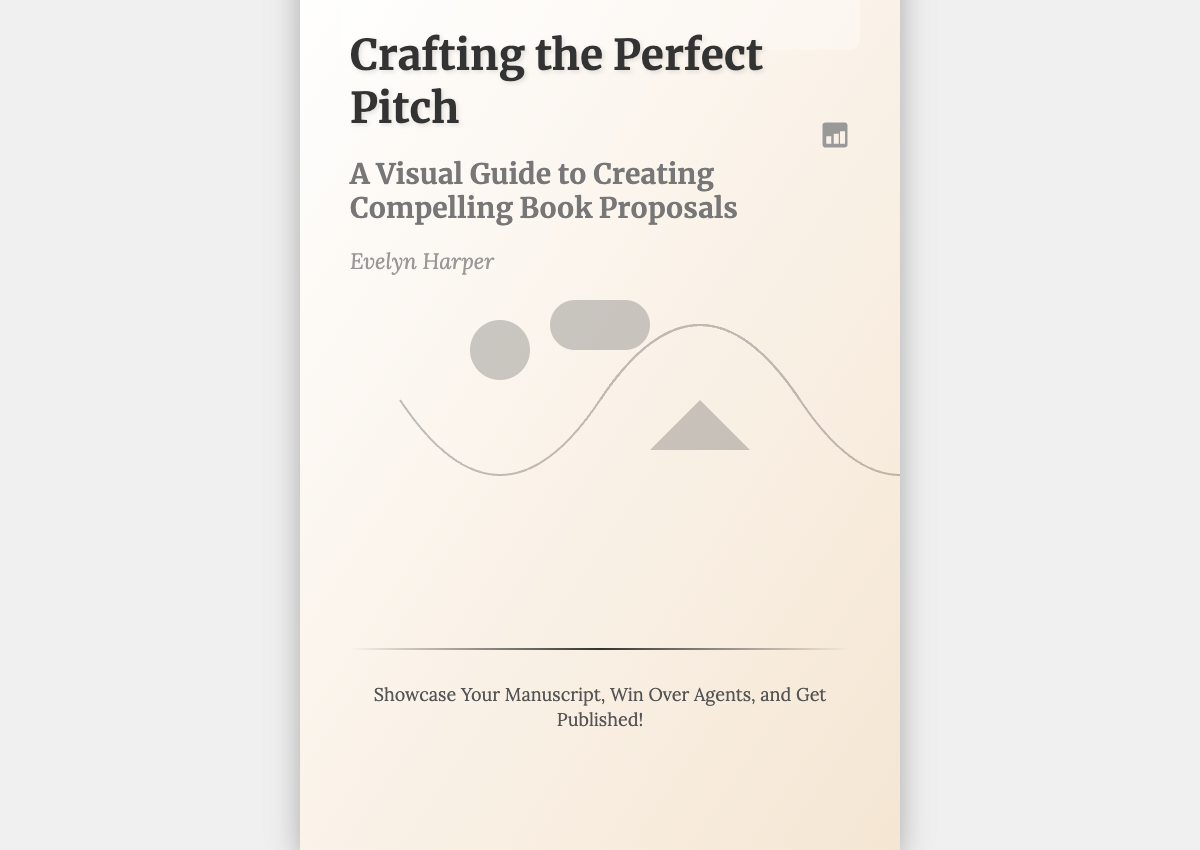What is the title of the book? The title is displayed prominently on the cover as the main title.
Answer: Crafting the Perfect Pitch Who is the author of the book? The author's name is shown clearly below the subtitle.
Answer: Evelyn Harper What is the subtitle of the book? The subtitle provides additional context about the content of the book.
Answer: A Visual Guide to Creating Compelling Book Proposals What is the tagline of the book? The tagline is a catchy phrase that summarizes the book's purpose.
Answer: Showcase Your Manuscript, Win Over Agents, and Get Published! What color is the book's highlight box? The highlight box's color can be observed in the design.
Answer: Transparent white What visual element appears at the top right corner? This element adds a design feature specific to the book cover's aesthetic.
Answer: Visual icon How many sections does the title information have? The title information is organized into distinct sections.
Answer: Three What is the background gradient of the book cover? The visual depiction of the background includes multiple colors blended together.
Answer: White to light beige What kind of guide is the book classified as? This categorization indicates the nature of the book’s content.
Answer: Visual guide 